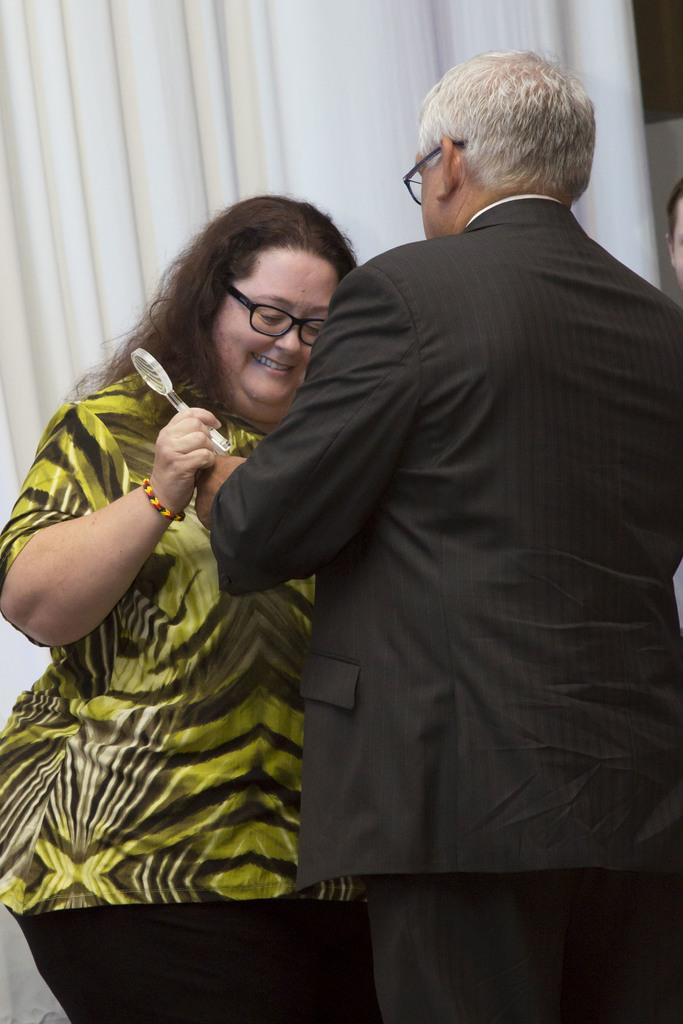How many people are present in the image? There are two people in the image. What can be seen in the background of the image? There is a white color curtain in the image. What is the woman in the image wearing? The woman in the image is wearing a green color dress. What type of notebook is the woman holding in the image? There is no notebook present in the image. Can you tell me how many cattle are visible in the image? There are no cattle visible in the image. 